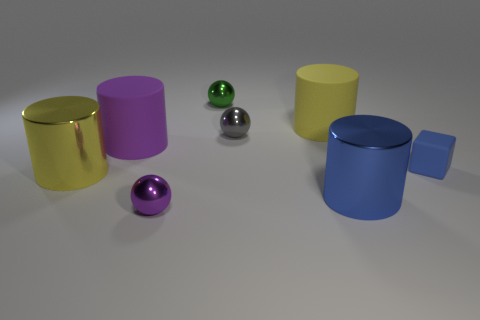Add 1 tiny yellow matte spheres. How many objects exist? 9 Subtract all blocks. How many objects are left? 7 Subtract 0 cyan cylinders. How many objects are left? 8 Subtract all tiny gray rubber spheres. Subtract all tiny blue rubber cubes. How many objects are left? 7 Add 8 large blue cylinders. How many large blue cylinders are left? 9 Add 2 tiny matte blocks. How many tiny matte blocks exist? 3 